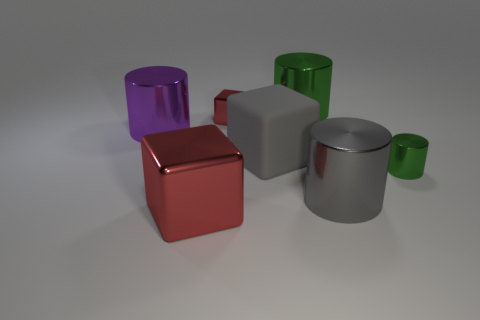Add 1 gray shiny things. How many objects exist? 8 Subtract all cylinders. How many objects are left? 3 Add 1 gray rubber balls. How many gray rubber balls exist? 1 Subtract 0 green blocks. How many objects are left? 7 Subtract all big shiny cubes. Subtract all green shiny things. How many objects are left? 4 Add 5 tiny objects. How many tiny objects are left? 7 